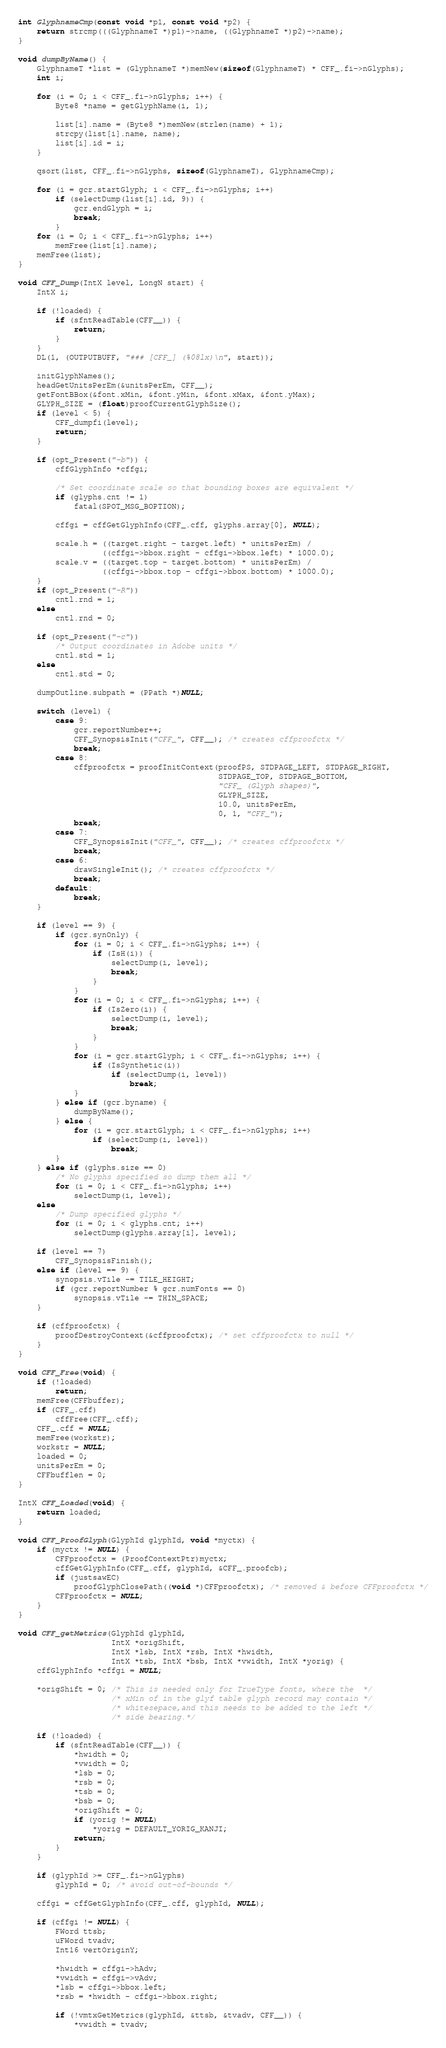Convert code to text. <code><loc_0><loc_0><loc_500><loc_500><_C_>
int GlyphnameCmp(const void *p1, const void *p2) {
    return strcmp(((GlyphnameT *)p1)->name, ((GlyphnameT *)p2)->name);
}

void dumpByName() {
    GlyphnameT *list = (GlyphnameT *)memNew(sizeof(GlyphnameT) * CFF_.fi->nGlyphs);
    int i;

    for (i = 0; i < CFF_.fi->nGlyphs; i++) {
        Byte8 *name = getGlyphName(i, 1);

        list[i].name = (Byte8 *)memNew(strlen(name) + 1);
        strcpy(list[i].name, name);
        list[i].id = i;
    }

    qsort(list, CFF_.fi->nGlyphs, sizeof(GlyphnameT), GlyphnameCmp);

    for (i = gcr.startGlyph; i < CFF_.fi->nGlyphs; i++)
        if (selectDump(list[i].id, 9)) {
            gcr.endGlyph = i;
            break;
        }
    for (i = 0; i < CFF_.fi->nGlyphs; i++)
        memFree(list[i].name);
    memFree(list);
}

void CFF_Dump(IntX level, LongN start) {
    IntX i;

    if (!loaded) {
        if (sfntReadTable(CFF__)) {
            return;
        }
    }
    DL(1, (OUTPUTBUFF, "### [CFF_] (%08lx)\n", start));

    initGlyphNames();
    headGetUnitsPerEm(&unitsPerEm, CFF__);
    getFontBBox(&font.xMin, &font.yMin, &font.xMax, &font.yMax);
    GLYPH_SIZE = (float)proofCurrentGlyphSize();
    if (level < 5) {
        CFF_dumpfi(level);
        return;
    }

    if (opt_Present("-b")) {
        cffGlyphInfo *cffgi;

        /* Set coordinate scale so that bounding boxes are equivalent */
        if (glyphs.cnt != 1)
            fatal(SPOT_MSG_BOPTION);

        cffgi = cffGetGlyphInfo(CFF_.cff, glyphs.array[0], NULL);

        scale.h = ((target.right - target.left) * unitsPerEm) /
                  ((cffgi->bbox.right - cffgi->bbox.left) * 1000.0);
        scale.v = ((target.top - target.bottom) * unitsPerEm) /
                  ((cffgi->bbox.top - cffgi->bbox.bottom) * 1000.0);
    }
    if (opt_Present("-R"))
        cntl.rnd = 1;
    else
        cntl.rnd = 0;

    if (opt_Present("-c"))
        /* Output coordinates in Adobe units */
        cntl.std = 1;
    else
        cntl.std = 0;

    dumpOutline.subpath = (PPath *)NULL;

    switch (level) {
        case 9:
            gcr.reportNumber++;
            CFF_SynopsisInit("CFF_", CFF__); /* creates cffproofctx */
            break;
        case 8:
            cffproofctx = proofInitContext(proofPS, STDPAGE_LEFT, STDPAGE_RIGHT,
                                           STDPAGE_TOP, STDPAGE_BOTTOM,
                                           "CFF_ (Glyph shapes)",
                                           GLYPH_SIZE,
                                           10.0, unitsPerEm,
                                           0, 1, "CFF_");
            break;
        case 7:
            CFF_SynopsisInit("CFF_", CFF__); /* creates cffproofctx */
            break;
        case 6:
            drawSingleInit(); /* creates cffproofctx */
            break;
        default:
            break;
    }

    if (level == 9) {
        if (gcr.synOnly) {
            for (i = 0; i < CFF_.fi->nGlyphs; i++) {
                if (IsH(i)) {
                    selectDump(i, level);
                    break;
                }
            }
            for (i = 0; i < CFF_.fi->nGlyphs; i++) {
                if (IsZero(i)) {
                    selectDump(i, level);
                    break;
                }
            }
            for (i = gcr.startGlyph; i < CFF_.fi->nGlyphs; i++) {
                if (IsSynthetic(i))
                    if (selectDump(i, level))
                        break;
            }
        } else if (gcr.byname) {
            dumpByName();
        } else {
            for (i = gcr.startGlyph; i < CFF_.fi->nGlyphs; i++)
                if (selectDump(i, level))
                    break;
        }
    } else if (glyphs.size == 0)
        /* No glyphs specified so dump them all */
        for (i = 0; i < CFF_.fi->nGlyphs; i++)
            selectDump(i, level);
    else
        /* Dump specified glyphs */
        for (i = 0; i < glyphs.cnt; i++)
            selectDump(glyphs.array[i], level);

    if (level == 7)
        CFF_SynopsisFinish();
    else if (level == 9) {
        synopsis.vTile -= TILE_HEIGHT;
        if (gcr.reportNumber % gcr.numFonts == 0)
            synopsis.vTile -= THIN_SPACE;
    }

    if (cffproofctx) {
        proofDestroyContext(&cffproofctx); /* set cffproofctx to null */
    }
}

void CFF_Free(void) {
    if (!loaded)
        return;
    memFree(CFFbuffer);
    if (CFF_.cff)
        cffFree(CFF_.cff);
    CFF_.cff = NULL;
    memFree(workstr);
    workstr = NULL;
    loaded = 0;
    unitsPerEm = 0;
    CFFbufflen = 0;
}

IntX CFF_Loaded(void) {
    return loaded;
}

void CFF_ProofGlyph(GlyphId glyphId, void *myctx) {
    if (myctx != NULL) {
        CFFproofctx = (ProofContextPtr)myctx;
        cffGetGlyphInfo(CFF_.cff, glyphId, &CFF_.proofcb);
        if (justsawEC)
            proofGlyphClosePath((void *)CFFproofctx); /* removed & before CFFproofctx */
        CFFproofctx = NULL;
    }
}

void CFF_getMetrics(GlyphId glyphId,
                    IntX *origShift,
                    IntX *lsb, IntX *rsb, IntX *hwidth,
                    IntX *tsb, IntX *bsb, IntX *vwidth, IntX *yorig) {
    cffGlyphInfo *cffgi = NULL;

    *origShift = 0; /* This is needed only for TrueType fonts, where the  */
                    /* xMin of in the glyf table glyph record may contain */
                    /* whitesepace,and this needs to be added to the left */
                    /* side bearing.*/

    if (!loaded) {
        if (sfntReadTable(CFF__)) {
            *hwidth = 0;
            *vwidth = 0;
            *lsb = 0;
            *rsb = 0;
            *tsb = 0;
            *bsb = 0;
            *origShift = 0;
            if (yorig != NULL)
                *yorig = DEFAULT_YORIG_KANJI;
            return;
        }
    }

    if (glyphId >= CFF_.fi->nGlyphs)
        glyphId = 0; /* avoid out-of-bounds */

    cffgi = cffGetGlyphInfo(CFF_.cff, glyphId, NULL);

    if (cffgi != NULL) {
        FWord ttsb;
        uFWord tvadv;
        Int16 vertOriginY;

        *hwidth = cffgi->hAdv;
        *vwidth = cffgi->vAdv;
        *lsb = cffgi->bbox.left;
        *rsb = *hwidth - cffgi->bbox.right;

        if (!vmtxGetMetrics(glyphId, &ttsb, &tvadv, CFF__)) {
            *vwidth = tvadv;</code> 